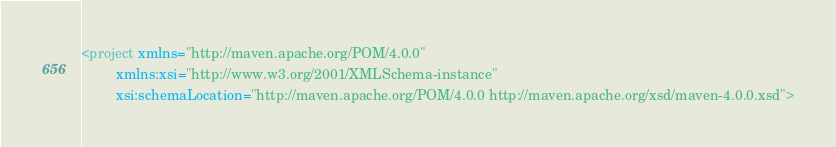<code> <loc_0><loc_0><loc_500><loc_500><_XML_><project xmlns="http://maven.apache.org/POM/4.0.0"
         xmlns:xsi="http://www.w3.org/2001/XMLSchema-instance"
         xsi:schemaLocation="http://maven.apache.org/POM/4.0.0 http://maven.apache.org/xsd/maven-4.0.0.xsd"></code> 